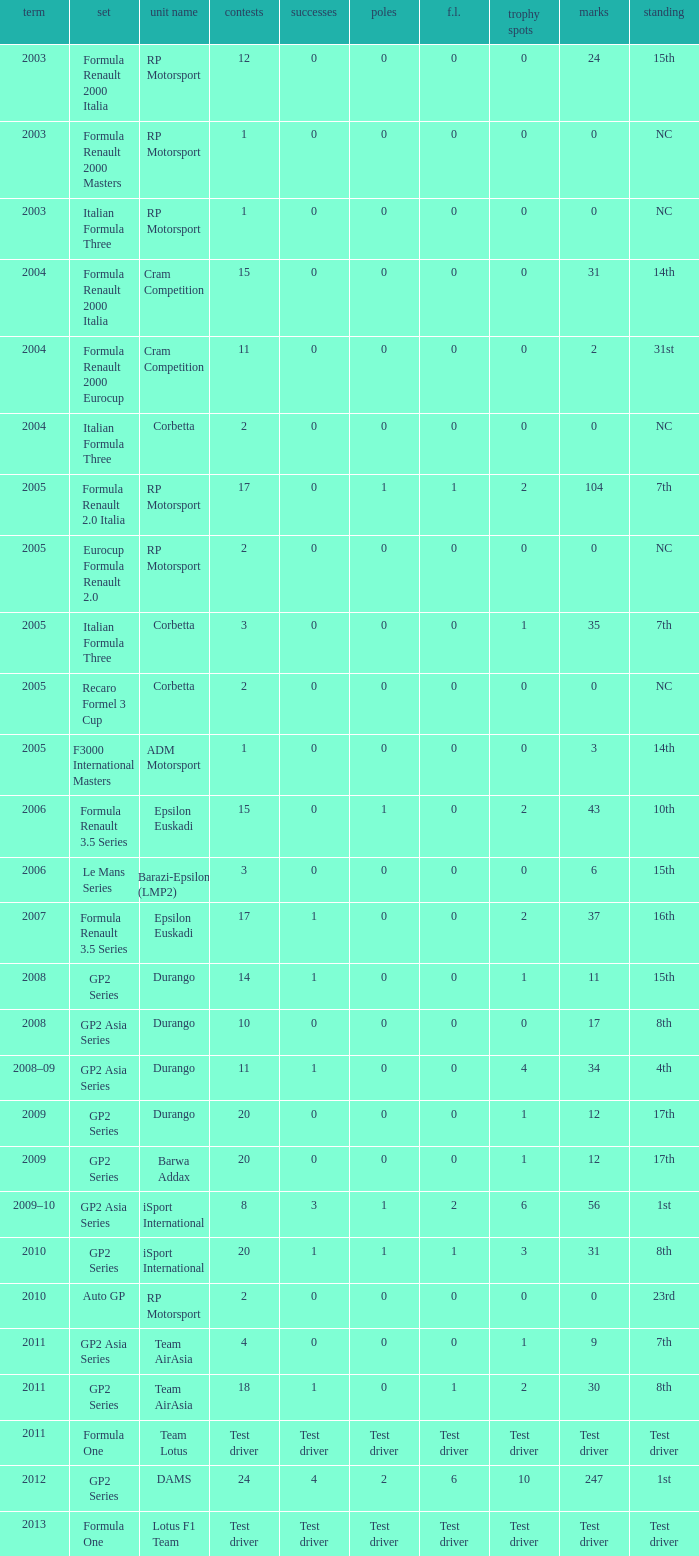What is the number of wins with a 0 F.L., 0 poles, a position of 7th, and 35 points? 0.0. 